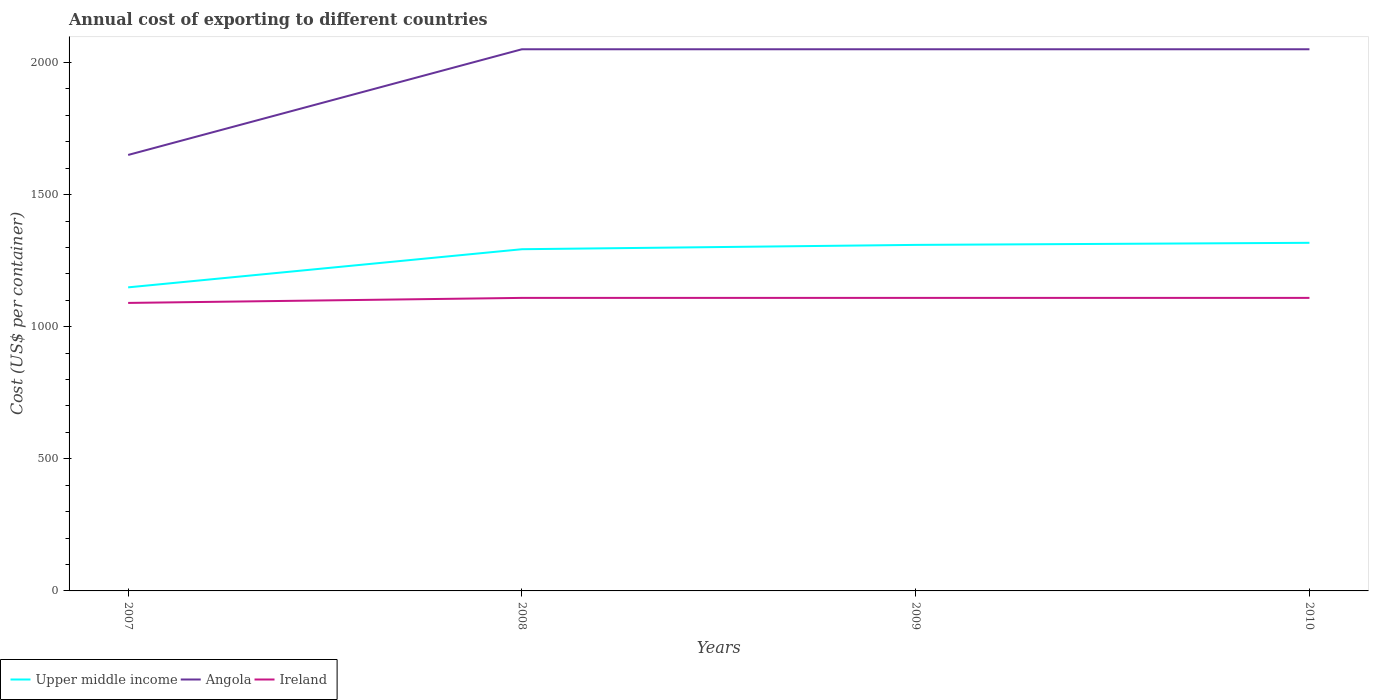Does the line corresponding to Angola intersect with the line corresponding to Upper middle income?
Your answer should be very brief. No. Is the number of lines equal to the number of legend labels?
Your answer should be compact. Yes. Across all years, what is the maximum total annual cost of exporting in Ireland?
Your response must be concise. 1090. What is the total total annual cost of exporting in Ireland in the graph?
Make the answer very short. 0. What is the difference between the highest and the second highest total annual cost of exporting in Upper middle income?
Your answer should be compact. 168.58. How many lines are there?
Provide a short and direct response. 3. How many years are there in the graph?
Provide a succinct answer. 4. What is the difference between two consecutive major ticks on the Y-axis?
Your answer should be compact. 500. Are the values on the major ticks of Y-axis written in scientific E-notation?
Provide a short and direct response. No. Does the graph contain any zero values?
Provide a short and direct response. No. What is the title of the graph?
Your response must be concise. Annual cost of exporting to different countries. Does "American Samoa" appear as one of the legend labels in the graph?
Give a very brief answer. No. What is the label or title of the X-axis?
Offer a terse response. Years. What is the label or title of the Y-axis?
Provide a succinct answer. Cost (US$ per container). What is the Cost (US$ per container) of Upper middle income in 2007?
Provide a short and direct response. 1148.88. What is the Cost (US$ per container) in Angola in 2007?
Provide a succinct answer. 1650. What is the Cost (US$ per container) in Ireland in 2007?
Your answer should be very brief. 1090. What is the Cost (US$ per container) in Upper middle income in 2008?
Give a very brief answer. 1293.21. What is the Cost (US$ per container) of Angola in 2008?
Provide a short and direct response. 2050. What is the Cost (US$ per container) in Ireland in 2008?
Offer a terse response. 1109. What is the Cost (US$ per container) of Upper middle income in 2009?
Keep it short and to the point. 1309.58. What is the Cost (US$ per container) in Angola in 2009?
Keep it short and to the point. 2050. What is the Cost (US$ per container) in Ireland in 2009?
Your answer should be compact. 1109. What is the Cost (US$ per container) in Upper middle income in 2010?
Your answer should be very brief. 1317.46. What is the Cost (US$ per container) in Angola in 2010?
Offer a terse response. 2050. What is the Cost (US$ per container) in Ireland in 2010?
Provide a succinct answer. 1109. Across all years, what is the maximum Cost (US$ per container) in Upper middle income?
Your answer should be compact. 1317.46. Across all years, what is the maximum Cost (US$ per container) of Angola?
Your response must be concise. 2050. Across all years, what is the maximum Cost (US$ per container) of Ireland?
Give a very brief answer. 1109. Across all years, what is the minimum Cost (US$ per container) in Upper middle income?
Your answer should be very brief. 1148.88. Across all years, what is the minimum Cost (US$ per container) of Angola?
Give a very brief answer. 1650. Across all years, what is the minimum Cost (US$ per container) in Ireland?
Keep it short and to the point. 1090. What is the total Cost (US$ per container) in Upper middle income in the graph?
Offer a very short reply. 5069.12. What is the total Cost (US$ per container) in Angola in the graph?
Offer a terse response. 7800. What is the total Cost (US$ per container) of Ireland in the graph?
Ensure brevity in your answer.  4417. What is the difference between the Cost (US$ per container) of Upper middle income in 2007 and that in 2008?
Your response must be concise. -144.33. What is the difference between the Cost (US$ per container) of Angola in 2007 and that in 2008?
Give a very brief answer. -400. What is the difference between the Cost (US$ per container) of Ireland in 2007 and that in 2008?
Offer a terse response. -19. What is the difference between the Cost (US$ per container) of Upper middle income in 2007 and that in 2009?
Provide a short and direct response. -160.71. What is the difference between the Cost (US$ per container) of Angola in 2007 and that in 2009?
Provide a succinct answer. -400. What is the difference between the Cost (US$ per container) of Ireland in 2007 and that in 2009?
Your answer should be very brief. -19. What is the difference between the Cost (US$ per container) of Upper middle income in 2007 and that in 2010?
Offer a terse response. -168.58. What is the difference between the Cost (US$ per container) of Angola in 2007 and that in 2010?
Your answer should be compact. -400. What is the difference between the Cost (US$ per container) in Ireland in 2007 and that in 2010?
Provide a short and direct response. -19. What is the difference between the Cost (US$ per container) in Upper middle income in 2008 and that in 2009?
Your answer should be very brief. -16.38. What is the difference between the Cost (US$ per container) of Ireland in 2008 and that in 2009?
Ensure brevity in your answer.  0. What is the difference between the Cost (US$ per container) of Upper middle income in 2008 and that in 2010?
Your answer should be compact. -24.25. What is the difference between the Cost (US$ per container) of Ireland in 2008 and that in 2010?
Offer a terse response. 0. What is the difference between the Cost (US$ per container) in Upper middle income in 2009 and that in 2010?
Make the answer very short. -7.88. What is the difference between the Cost (US$ per container) of Upper middle income in 2007 and the Cost (US$ per container) of Angola in 2008?
Your answer should be very brief. -901.12. What is the difference between the Cost (US$ per container) in Upper middle income in 2007 and the Cost (US$ per container) in Ireland in 2008?
Keep it short and to the point. 39.88. What is the difference between the Cost (US$ per container) in Angola in 2007 and the Cost (US$ per container) in Ireland in 2008?
Provide a succinct answer. 541. What is the difference between the Cost (US$ per container) of Upper middle income in 2007 and the Cost (US$ per container) of Angola in 2009?
Keep it short and to the point. -901.12. What is the difference between the Cost (US$ per container) of Upper middle income in 2007 and the Cost (US$ per container) of Ireland in 2009?
Your response must be concise. 39.88. What is the difference between the Cost (US$ per container) in Angola in 2007 and the Cost (US$ per container) in Ireland in 2009?
Keep it short and to the point. 541. What is the difference between the Cost (US$ per container) of Upper middle income in 2007 and the Cost (US$ per container) of Angola in 2010?
Provide a short and direct response. -901.12. What is the difference between the Cost (US$ per container) in Upper middle income in 2007 and the Cost (US$ per container) in Ireland in 2010?
Your answer should be very brief. 39.88. What is the difference between the Cost (US$ per container) in Angola in 2007 and the Cost (US$ per container) in Ireland in 2010?
Offer a terse response. 541. What is the difference between the Cost (US$ per container) of Upper middle income in 2008 and the Cost (US$ per container) of Angola in 2009?
Keep it short and to the point. -756.79. What is the difference between the Cost (US$ per container) of Upper middle income in 2008 and the Cost (US$ per container) of Ireland in 2009?
Offer a terse response. 184.21. What is the difference between the Cost (US$ per container) of Angola in 2008 and the Cost (US$ per container) of Ireland in 2009?
Your answer should be very brief. 941. What is the difference between the Cost (US$ per container) of Upper middle income in 2008 and the Cost (US$ per container) of Angola in 2010?
Your answer should be very brief. -756.79. What is the difference between the Cost (US$ per container) in Upper middle income in 2008 and the Cost (US$ per container) in Ireland in 2010?
Ensure brevity in your answer.  184.21. What is the difference between the Cost (US$ per container) in Angola in 2008 and the Cost (US$ per container) in Ireland in 2010?
Ensure brevity in your answer.  941. What is the difference between the Cost (US$ per container) in Upper middle income in 2009 and the Cost (US$ per container) in Angola in 2010?
Offer a very short reply. -740.42. What is the difference between the Cost (US$ per container) in Upper middle income in 2009 and the Cost (US$ per container) in Ireland in 2010?
Give a very brief answer. 200.58. What is the difference between the Cost (US$ per container) of Angola in 2009 and the Cost (US$ per container) of Ireland in 2010?
Make the answer very short. 941. What is the average Cost (US$ per container) in Upper middle income per year?
Your answer should be very brief. 1267.28. What is the average Cost (US$ per container) of Angola per year?
Ensure brevity in your answer.  1950. What is the average Cost (US$ per container) of Ireland per year?
Your response must be concise. 1104.25. In the year 2007, what is the difference between the Cost (US$ per container) in Upper middle income and Cost (US$ per container) in Angola?
Your answer should be very brief. -501.12. In the year 2007, what is the difference between the Cost (US$ per container) of Upper middle income and Cost (US$ per container) of Ireland?
Your answer should be very brief. 58.88. In the year 2007, what is the difference between the Cost (US$ per container) of Angola and Cost (US$ per container) of Ireland?
Provide a succinct answer. 560. In the year 2008, what is the difference between the Cost (US$ per container) of Upper middle income and Cost (US$ per container) of Angola?
Ensure brevity in your answer.  -756.79. In the year 2008, what is the difference between the Cost (US$ per container) of Upper middle income and Cost (US$ per container) of Ireland?
Offer a very short reply. 184.21. In the year 2008, what is the difference between the Cost (US$ per container) of Angola and Cost (US$ per container) of Ireland?
Offer a terse response. 941. In the year 2009, what is the difference between the Cost (US$ per container) of Upper middle income and Cost (US$ per container) of Angola?
Your answer should be compact. -740.42. In the year 2009, what is the difference between the Cost (US$ per container) in Upper middle income and Cost (US$ per container) in Ireland?
Give a very brief answer. 200.58. In the year 2009, what is the difference between the Cost (US$ per container) of Angola and Cost (US$ per container) of Ireland?
Offer a terse response. 941. In the year 2010, what is the difference between the Cost (US$ per container) in Upper middle income and Cost (US$ per container) in Angola?
Your answer should be compact. -732.54. In the year 2010, what is the difference between the Cost (US$ per container) in Upper middle income and Cost (US$ per container) in Ireland?
Give a very brief answer. 208.46. In the year 2010, what is the difference between the Cost (US$ per container) in Angola and Cost (US$ per container) in Ireland?
Give a very brief answer. 941. What is the ratio of the Cost (US$ per container) in Upper middle income in 2007 to that in 2008?
Offer a very short reply. 0.89. What is the ratio of the Cost (US$ per container) of Angola in 2007 to that in 2008?
Keep it short and to the point. 0.8. What is the ratio of the Cost (US$ per container) in Ireland in 2007 to that in 2008?
Give a very brief answer. 0.98. What is the ratio of the Cost (US$ per container) in Upper middle income in 2007 to that in 2009?
Provide a succinct answer. 0.88. What is the ratio of the Cost (US$ per container) in Angola in 2007 to that in 2009?
Keep it short and to the point. 0.8. What is the ratio of the Cost (US$ per container) in Ireland in 2007 to that in 2009?
Provide a succinct answer. 0.98. What is the ratio of the Cost (US$ per container) in Upper middle income in 2007 to that in 2010?
Provide a short and direct response. 0.87. What is the ratio of the Cost (US$ per container) of Angola in 2007 to that in 2010?
Your response must be concise. 0.8. What is the ratio of the Cost (US$ per container) in Ireland in 2007 to that in 2010?
Make the answer very short. 0.98. What is the ratio of the Cost (US$ per container) in Upper middle income in 2008 to that in 2009?
Offer a very short reply. 0.99. What is the ratio of the Cost (US$ per container) of Angola in 2008 to that in 2009?
Provide a succinct answer. 1. What is the ratio of the Cost (US$ per container) in Ireland in 2008 to that in 2009?
Offer a terse response. 1. What is the ratio of the Cost (US$ per container) of Upper middle income in 2008 to that in 2010?
Offer a terse response. 0.98. What is the ratio of the Cost (US$ per container) in Angola in 2008 to that in 2010?
Your response must be concise. 1. What is the ratio of the Cost (US$ per container) of Ireland in 2008 to that in 2010?
Provide a succinct answer. 1. What is the ratio of the Cost (US$ per container) in Angola in 2009 to that in 2010?
Ensure brevity in your answer.  1. What is the difference between the highest and the second highest Cost (US$ per container) of Upper middle income?
Your answer should be very brief. 7.88. What is the difference between the highest and the second highest Cost (US$ per container) in Angola?
Offer a terse response. 0. What is the difference between the highest and the lowest Cost (US$ per container) in Upper middle income?
Ensure brevity in your answer.  168.58. What is the difference between the highest and the lowest Cost (US$ per container) of Angola?
Offer a terse response. 400. What is the difference between the highest and the lowest Cost (US$ per container) of Ireland?
Your response must be concise. 19. 